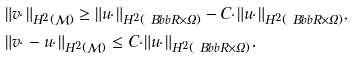<formula> <loc_0><loc_0><loc_500><loc_500>& \| v _ { \ell } \| _ { H ^ { 2 } ( \mathcal { M } ) } \geq \| u _ { \ell } \| _ { H ^ { 2 } ( \ B b b R \times \Omega ) } - C _ { \ell } \| u _ { \ell } \| _ { H ^ { 2 } ( \ B b b R \times \Omega ) } , \\ & \| v _ { \ell } - u _ { \ell } \| _ { H ^ { 2 } ( \mathcal { M } ) } \leq C _ { \ell } \| u _ { \ell } \| _ { H ^ { 2 } ( \ B b b R \times \Omega ) } .</formula> 